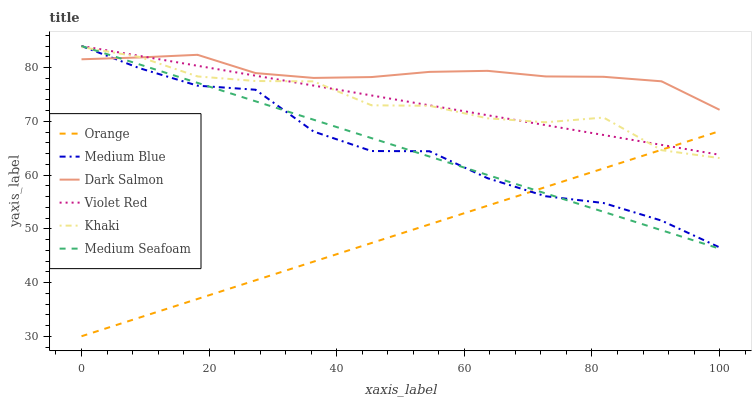Does Khaki have the minimum area under the curve?
Answer yes or no. No. Does Khaki have the maximum area under the curve?
Answer yes or no. No. Is Medium Blue the smoothest?
Answer yes or no. No. Is Medium Blue the roughest?
Answer yes or no. No. Does Khaki have the lowest value?
Answer yes or no. No. Does Khaki have the highest value?
Answer yes or no. No. Is Orange less than Dark Salmon?
Answer yes or no. Yes. Is Dark Salmon greater than Orange?
Answer yes or no. Yes. Does Orange intersect Dark Salmon?
Answer yes or no. No. 